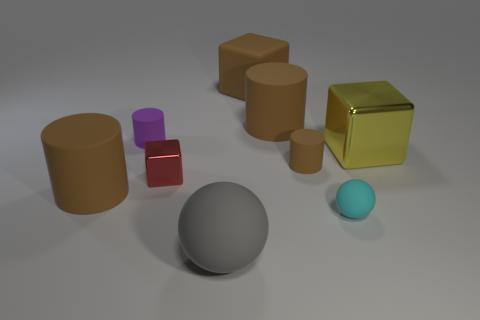How many brown cylinders must be subtracted to get 1 brown cylinders? 2 Subtract all gray cubes. How many brown cylinders are left? 3 Add 1 large rubber cubes. How many objects exist? 10 Subtract all blocks. How many objects are left? 6 Add 1 cubes. How many cubes exist? 4 Subtract 0 blue balls. How many objects are left? 9 Subtract all big red things. Subtract all large cylinders. How many objects are left? 7 Add 3 cylinders. How many cylinders are left? 7 